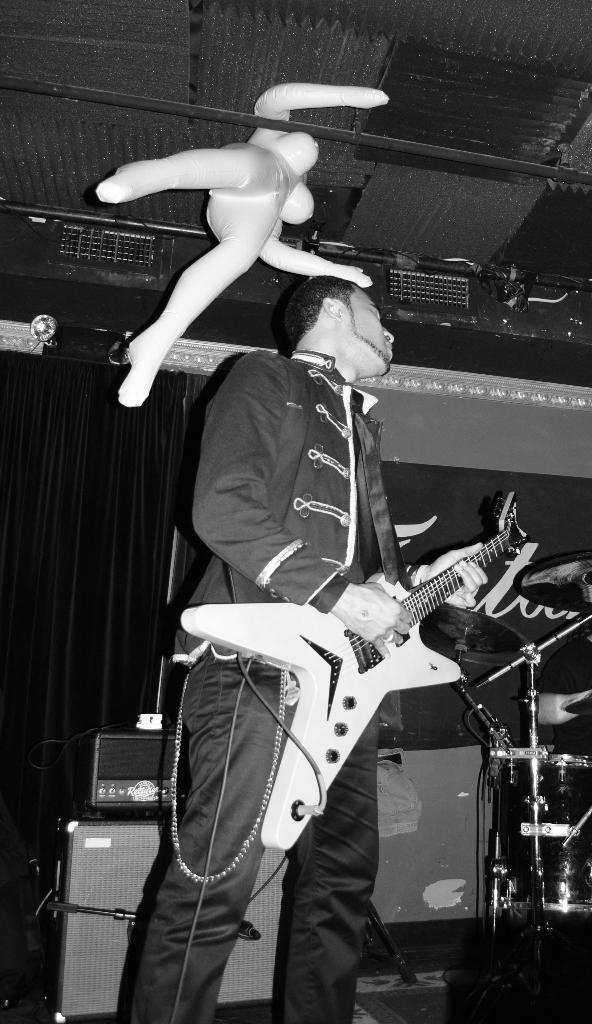What is the man in the image doing? The man is playing a guitar. What other musical instrument is visible in the image? There are drums beside the man. Is there anything else hanging from the top in the image? Yes, there is a mannequin hanging from the top. What type of gun can be seen in the hands of the mannequin? There is no gun present in the image; it only features a man playing a guitar, drums, and a hanging mannequin. 